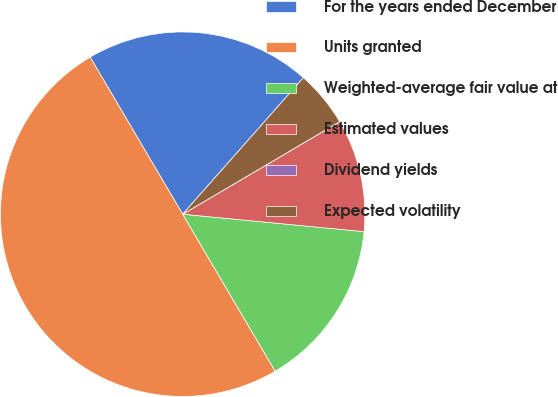Convert chart to OTSL. <chart><loc_0><loc_0><loc_500><loc_500><pie_chart><fcel>For the years ended December<fcel>Units granted<fcel>Weighted-average fair value at<fcel>Estimated values<fcel>Dividend yields<fcel>Expected volatility<nl><fcel>20.0%<fcel>50.0%<fcel>15.0%<fcel>10.0%<fcel>0.0%<fcel>5.0%<nl></chart> 